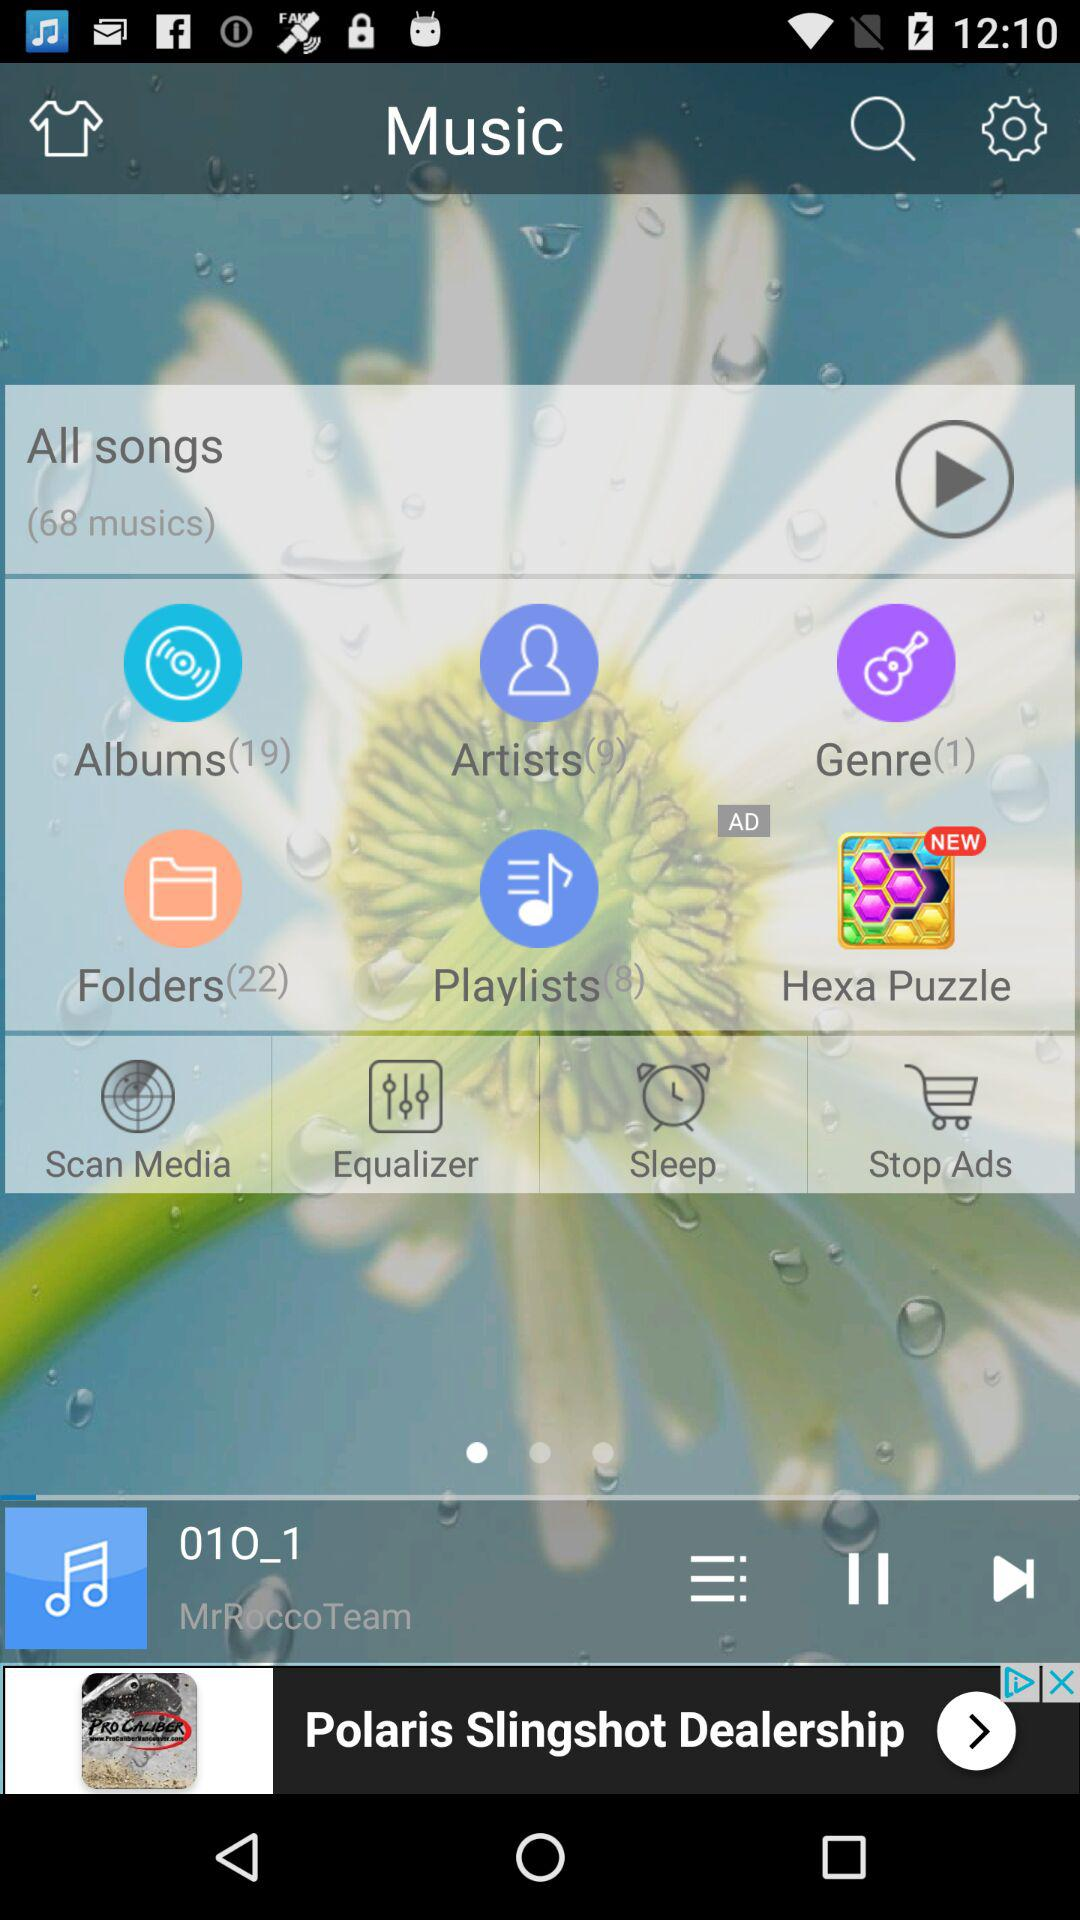In which folder 22 files are present? 22 files are present in "Folders". 